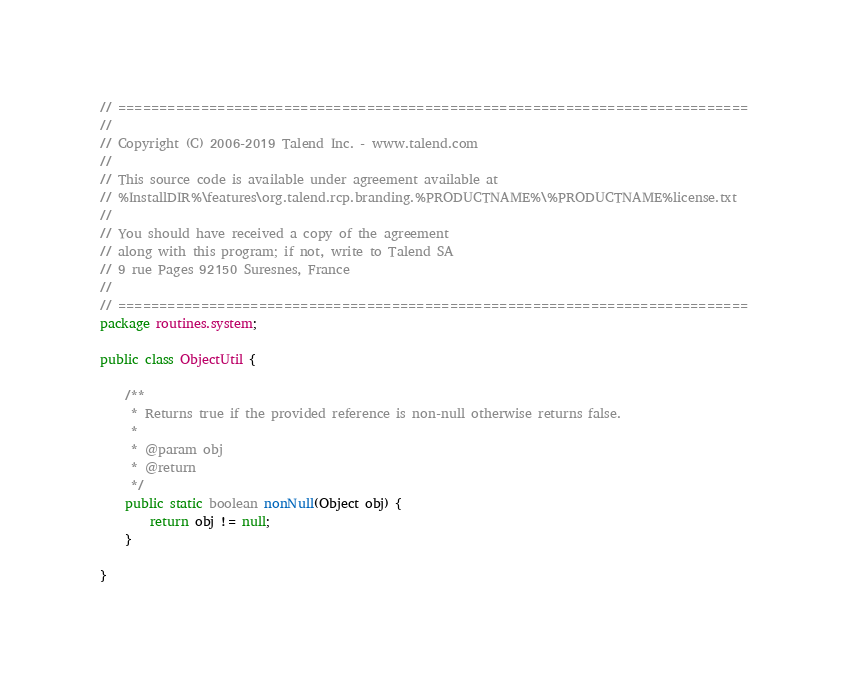Convert code to text. <code><loc_0><loc_0><loc_500><loc_500><_Java_>// ============================================================================
//
// Copyright (C) 2006-2019 Talend Inc. - www.talend.com
//
// This source code is available under agreement available at
// %InstallDIR%\features\org.talend.rcp.branding.%PRODUCTNAME%\%PRODUCTNAME%license.txt
//
// You should have received a copy of the agreement
// along with this program; if not, write to Talend SA
// 9 rue Pages 92150 Suresnes, France
//
// ============================================================================
package routines.system;

public class ObjectUtil {

    /**
     * Returns true if the provided reference is non-null otherwise returns false.
     *
     * @param obj
     * @return
     */
    public static boolean nonNull(Object obj) {
        return obj != null;
    }

}
</code> 